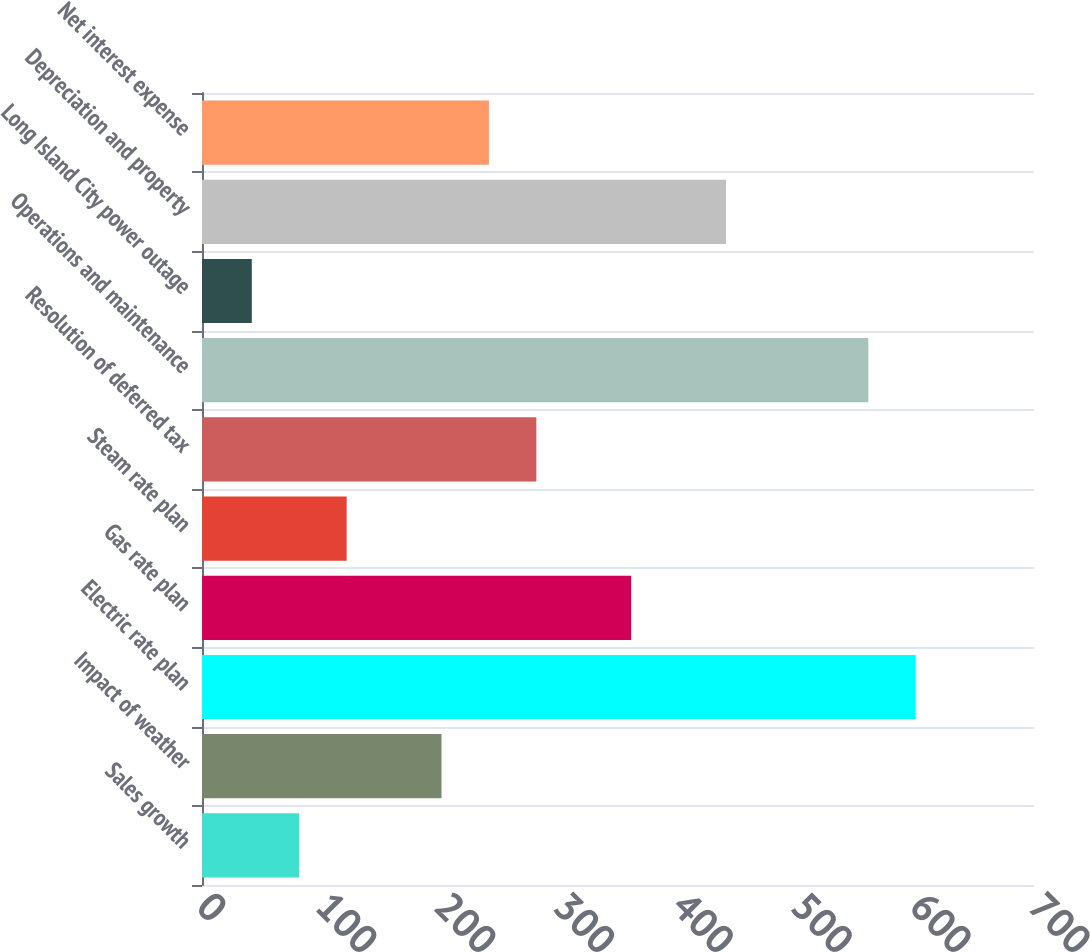Convert chart to OTSL. <chart><loc_0><loc_0><loc_500><loc_500><bar_chart><fcel>Sales growth<fcel>Impact of weather<fcel>Electric rate plan<fcel>Gas rate plan<fcel>Steam rate plan<fcel>Resolution of deferred tax<fcel>Operations and maintenance<fcel>Long Island City power outage<fcel>Depreciation and property<fcel>Net interest expense<nl><fcel>81.8<fcel>201.5<fcel>600.5<fcel>361.1<fcel>121.7<fcel>281.3<fcel>560.6<fcel>41.9<fcel>440.9<fcel>241.4<nl></chart> 